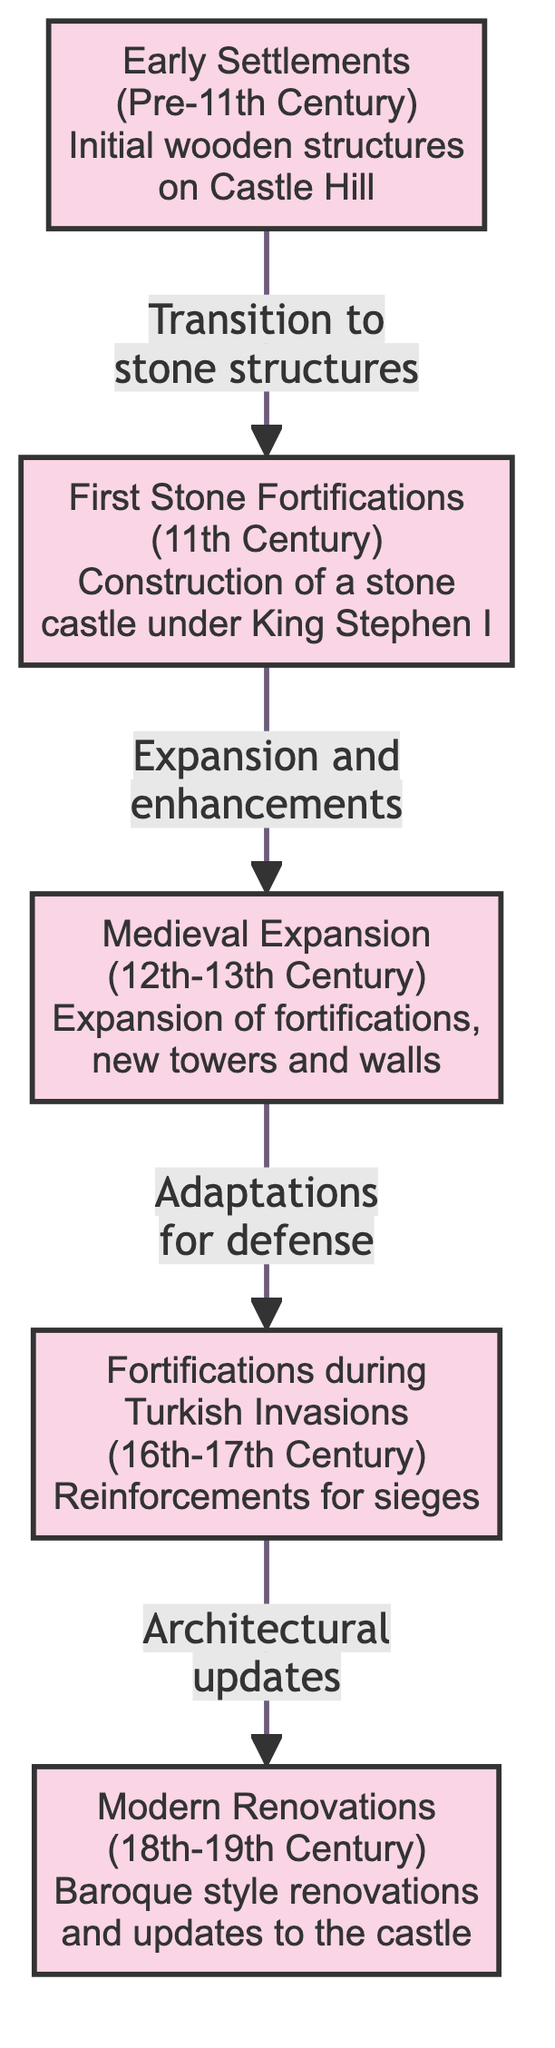What is the earliest phase of fortifications in Veszprém? The diagram identifies "Early Settlements" as the first node, which corresponds to the time before the 11th century when the initial wooden structures were built on Castle Hill.
Answer: Early Settlements During which century were the first stone fortifications constructed? Referring to the node for "First Stone Fortifications," it indicates that this phase occurred in the 11th Century during the reign of King Stephen I.
Answer: 11th Century What architectural style was featured in the modern renovations? The node labeled "Modern Renovations" mentions "Baroque style renovations," indicating the specific architectural influence during this time.
Answer: Baroque How many phases of fortifications are outlined in the diagram? By counting the nodes present in the diagram, there are five distinct phases of fortifications specified, each corresponding to a historical timeframe.
Answer: Five What significance is attributed to the period of the Turkish invasions? In the section regarding "Fortifications during Turkish Invasions," it states that this time was marked by "Reinforcements for sieges," highlighting the adaptive nature of the fortifications.
Answer: Reinforcements What type of adaptation occurred during the medieval expansion? The diagram states that during the "Medieval Expansion," there were "Expansion of fortifications, new towers and walls," indicating the kinds of enhancements made during this era.
Answer: Expansion and enhancements Which transition occurred between early settlements and first stone fortifications? The diagram indicates a transition labeled as "Transition to stone structures," signifying the shift from wooden to stone fortifications occurred in this period.
Answer: Transition to stone structures What updates were made during the Turkish invasions phase? The explanation in the "Fortifications during Turkish Invasions" node states that adaptations made were for defense, reflecting the need for improved security during this turbulent time.
Answer: Adaptations for defense 